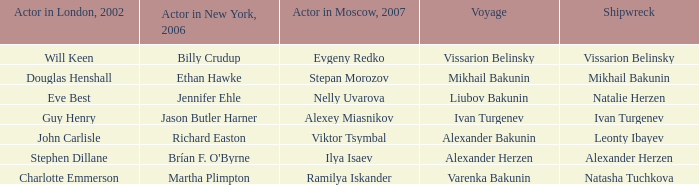Who was the 2007 actor from Moscow for the voyage of Varenka Bakunin? Ramilya Iskander. 